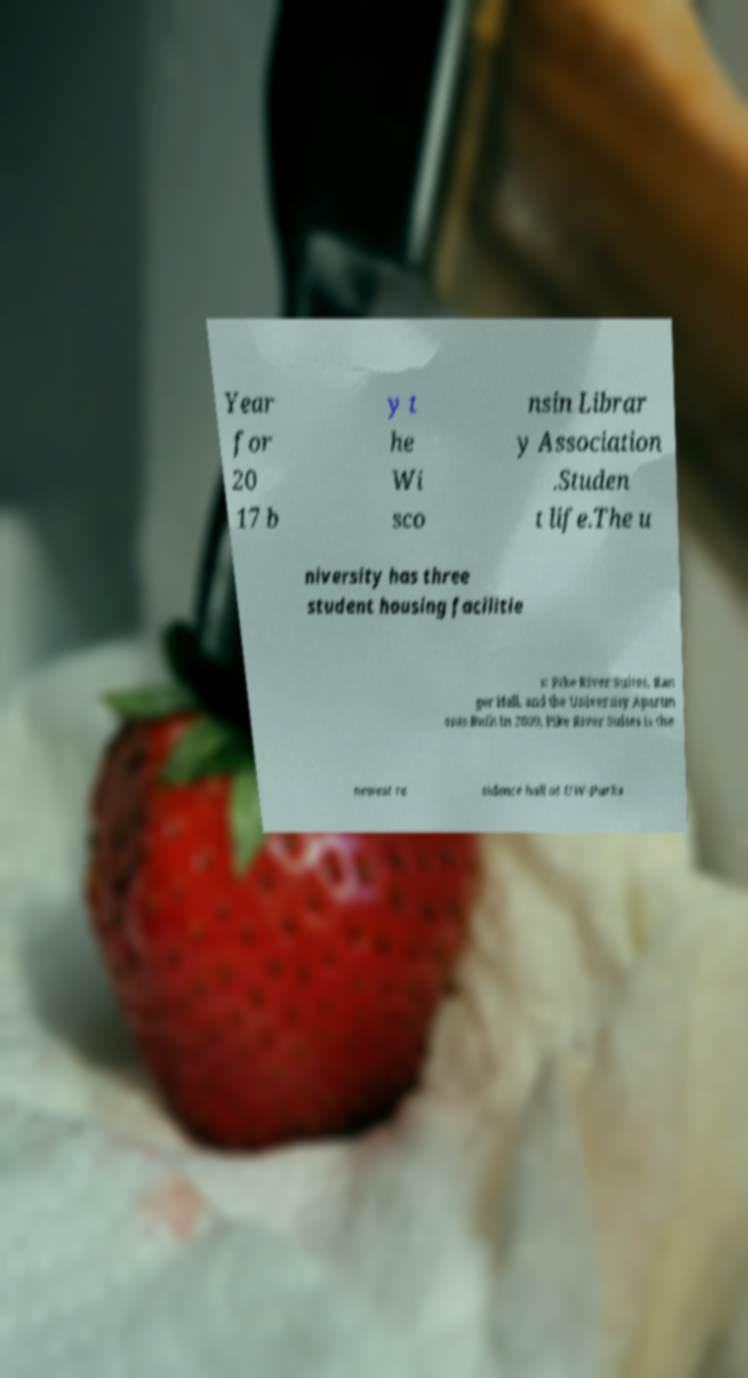What messages or text are displayed in this image? I need them in a readable, typed format. Year for 20 17 b y t he Wi sco nsin Librar y Association .Studen t life.The u niversity has three student housing facilitie s: Pike River Suites, Ran ger Hall, and the University Apartm ents.Built in 2009, Pike River Suites is the newest re sidence hall at UW-Parks 